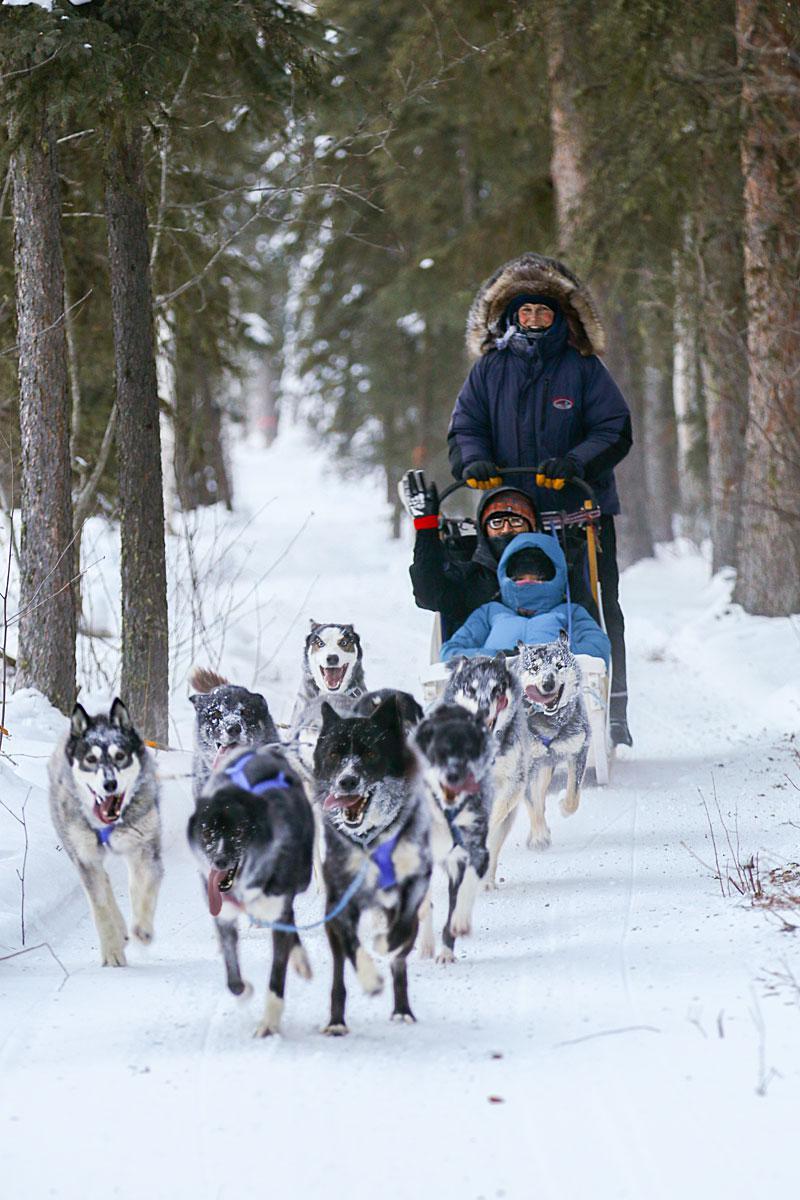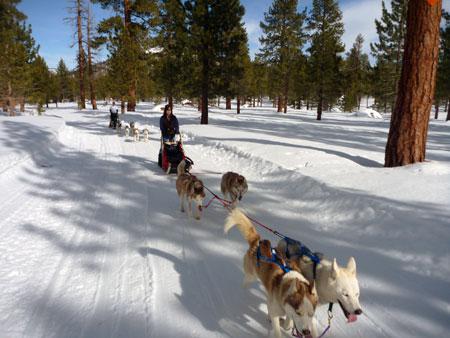The first image is the image on the left, the second image is the image on the right. Evaluate the accuracy of this statement regarding the images: "In the left image, all dogs have blue harnesses.". Is it true? Answer yes or no. Yes. The first image is the image on the left, the second image is the image on the right. For the images shown, is this caption "The dog sled teams in the left and right images move forward over snow at some angle [instead of away from the camera] but are not heading toward each other." true? Answer yes or no. Yes. 